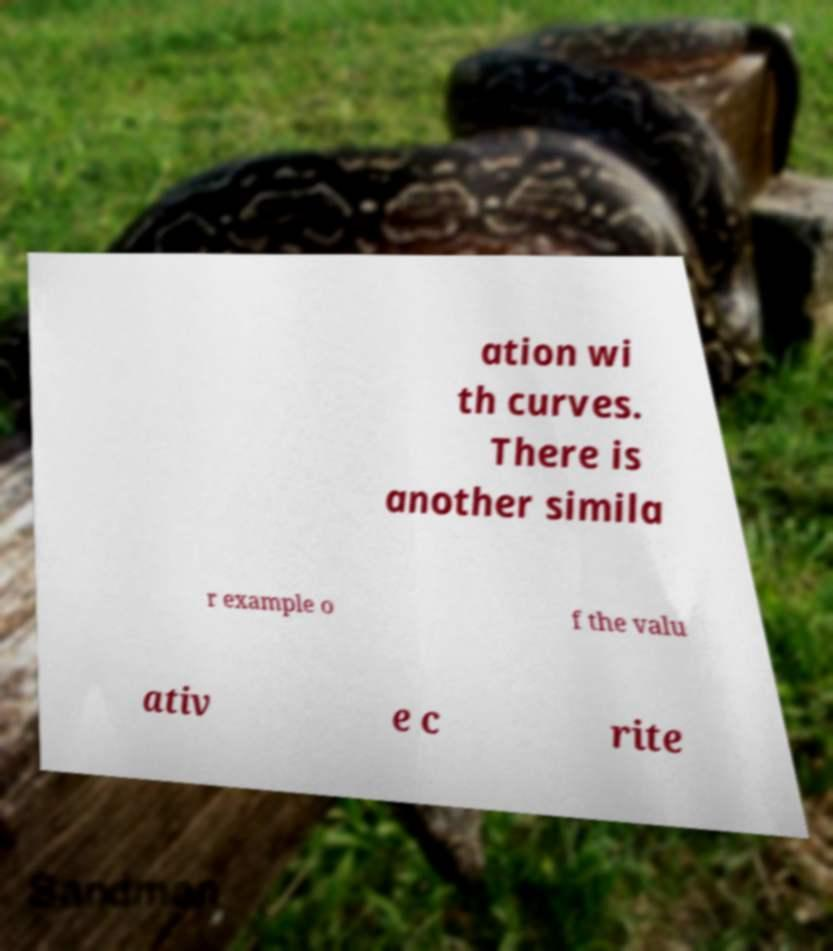For documentation purposes, I need the text within this image transcribed. Could you provide that? ation wi th curves. There is another simila r example o f the valu ativ e c rite 